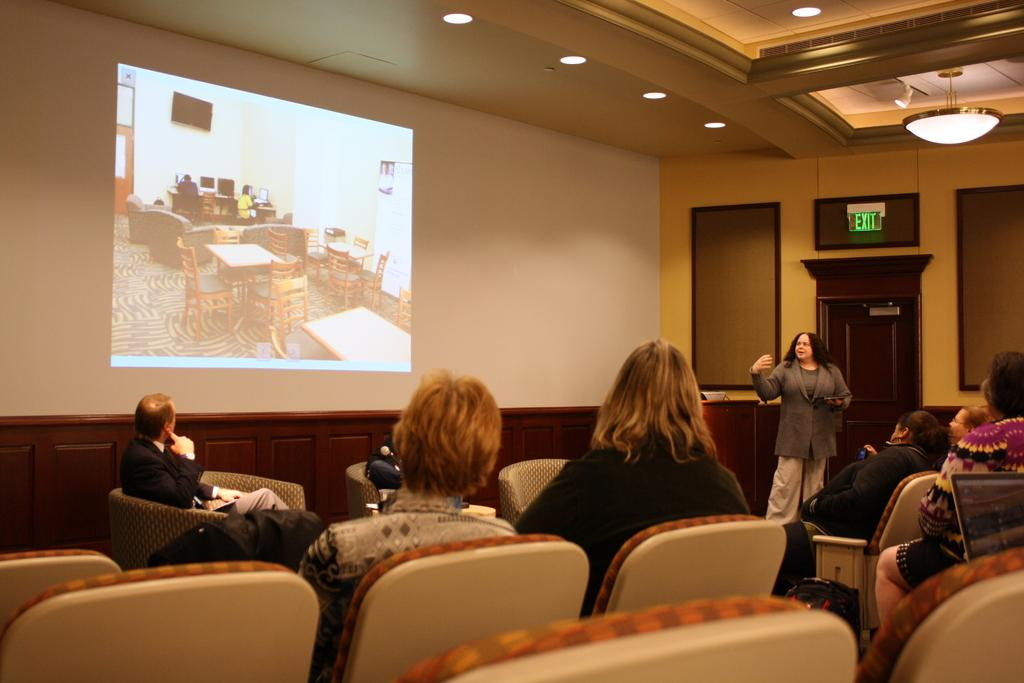What is the main object in the image? There is a screen in the image. Can you describe the lighting in the image? There is light in the image. What are the people in the image doing? There are people sitting on chairs in the image. What type of question is being asked by the yak in the image? There is no yak present in the image, so no question can be asked by a yak. 